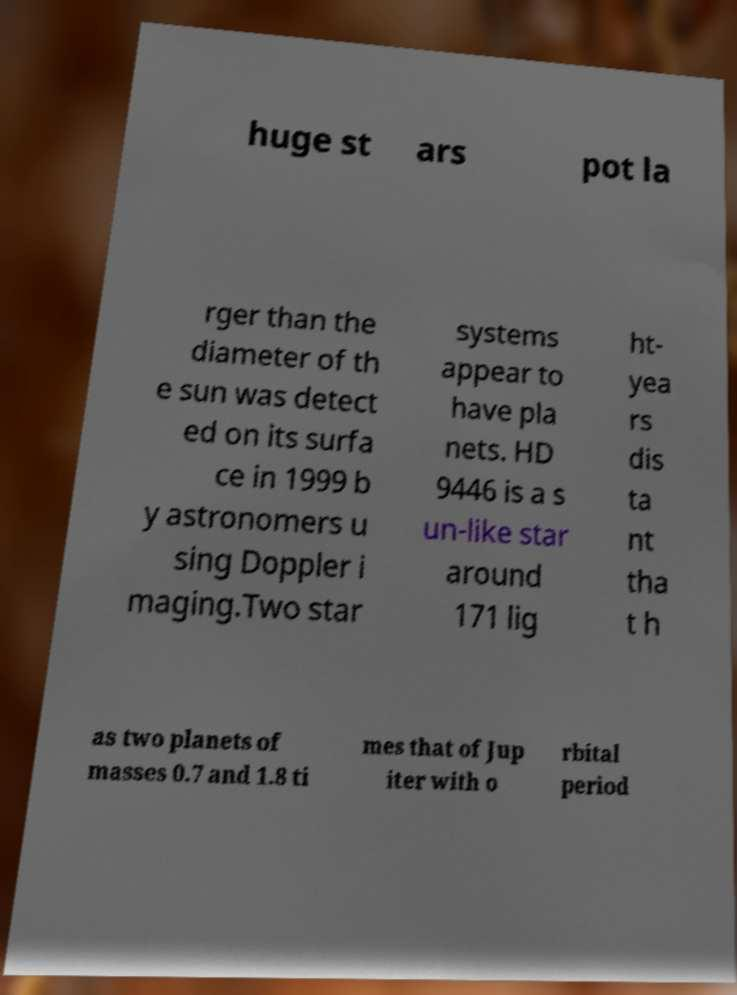There's text embedded in this image that I need extracted. Can you transcribe it verbatim? huge st ars pot la rger than the diameter of th e sun was detect ed on its surfa ce in 1999 b y astronomers u sing Doppler i maging.Two star systems appear to have pla nets. HD 9446 is a s un-like star around 171 lig ht- yea rs dis ta nt tha t h as two planets of masses 0.7 and 1.8 ti mes that of Jup iter with o rbital period 